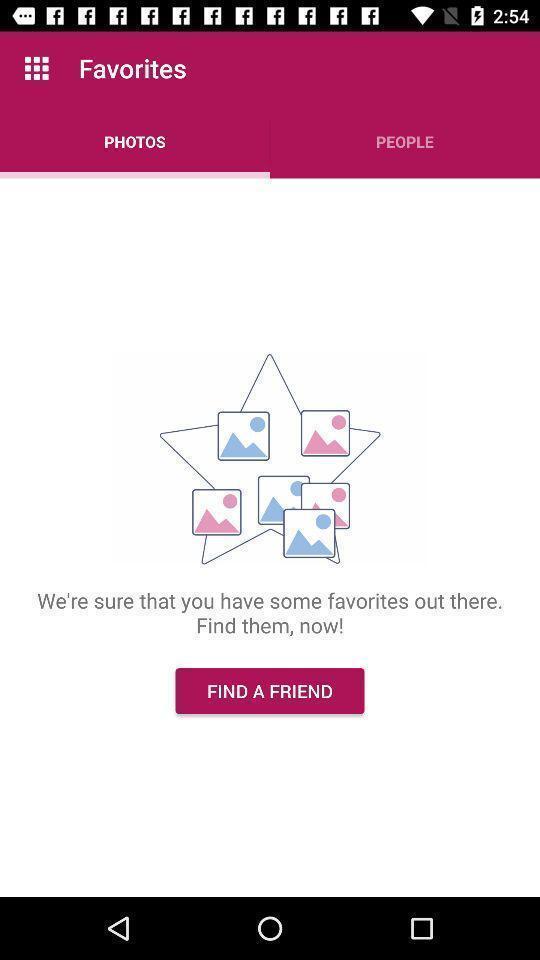Summarize the information in this screenshot. Page displays to find a friend from photos. 